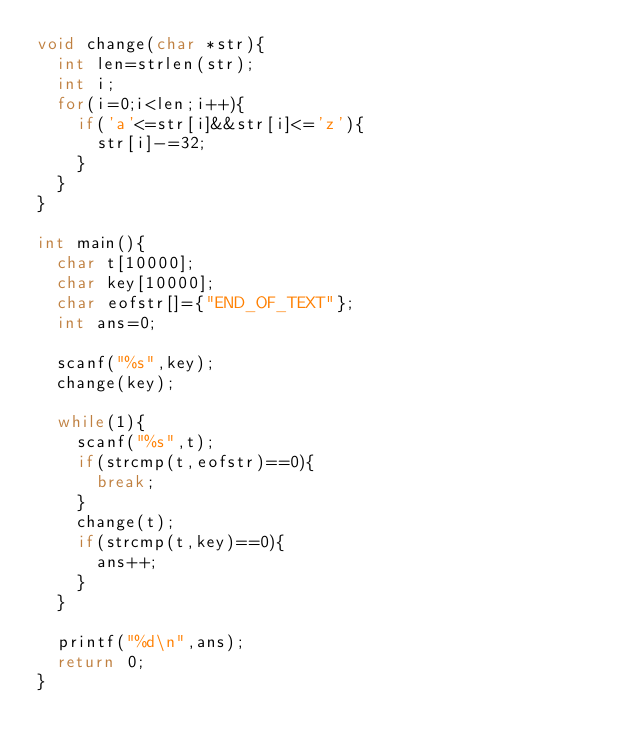Convert code to text. <code><loc_0><loc_0><loc_500><loc_500><_C_>void change(char *str){
  int len=strlen(str);
  int i;
  for(i=0;i<len;i++){
    if('a'<=str[i]&&str[i]<='z'){
      str[i]-=32;
    }
  }
}
 
int main(){
  char t[10000];
  char key[10000];
  char eofstr[]={"END_OF_TEXT"};
  int ans=0;
 
  scanf("%s",key);
  change(key);
 
  while(1){
    scanf("%s",t);
    if(strcmp(t,eofstr)==0){
      break;
    }
    change(t);
    if(strcmp(t,key)==0){
      ans++;
    }
  }
 
  printf("%d\n",ans);
  return 0;
}

</code> 